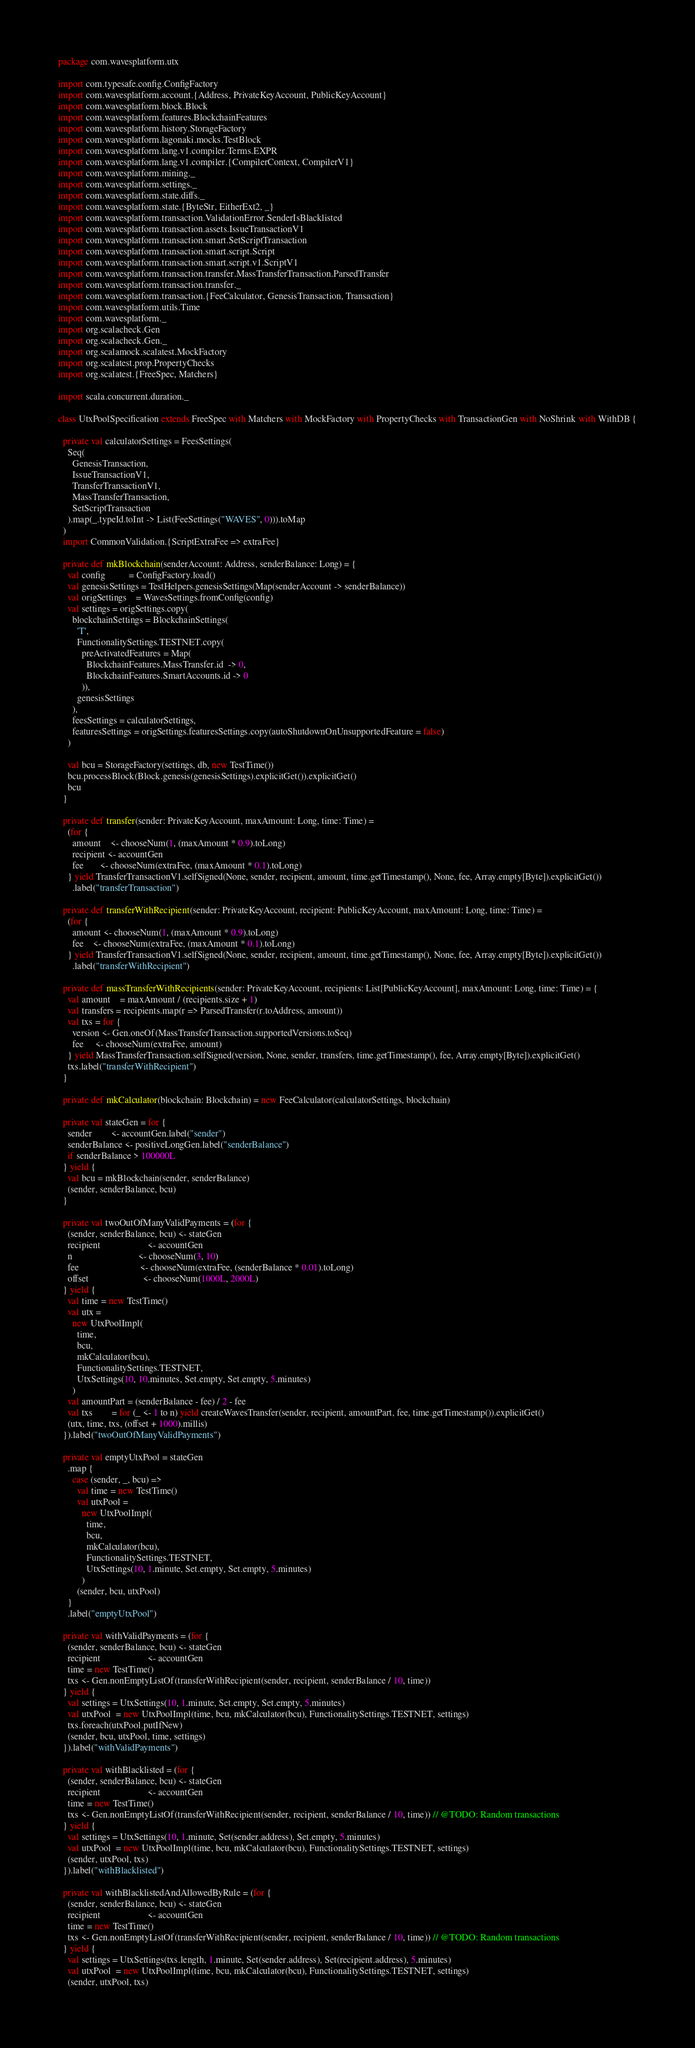<code> <loc_0><loc_0><loc_500><loc_500><_Scala_>package com.wavesplatform.utx

import com.typesafe.config.ConfigFactory
import com.wavesplatform.account.{Address, PrivateKeyAccount, PublicKeyAccount}
import com.wavesplatform.block.Block
import com.wavesplatform.features.BlockchainFeatures
import com.wavesplatform.history.StorageFactory
import com.wavesplatform.lagonaki.mocks.TestBlock
import com.wavesplatform.lang.v1.compiler.Terms.EXPR
import com.wavesplatform.lang.v1.compiler.{CompilerContext, CompilerV1}
import com.wavesplatform.mining._
import com.wavesplatform.settings._
import com.wavesplatform.state.diffs._
import com.wavesplatform.state.{ByteStr, EitherExt2, _}
import com.wavesplatform.transaction.ValidationError.SenderIsBlacklisted
import com.wavesplatform.transaction.assets.IssueTransactionV1
import com.wavesplatform.transaction.smart.SetScriptTransaction
import com.wavesplatform.transaction.smart.script.Script
import com.wavesplatform.transaction.smart.script.v1.ScriptV1
import com.wavesplatform.transaction.transfer.MassTransferTransaction.ParsedTransfer
import com.wavesplatform.transaction.transfer._
import com.wavesplatform.transaction.{FeeCalculator, GenesisTransaction, Transaction}
import com.wavesplatform.utils.Time
import com.wavesplatform._
import org.scalacheck.Gen
import org.scalacheck.Gen._
import org.scalamock.scalatest.MockFactory
import org.scalatest.prop.PropertyChecks
import org.scalatest.{FreeSpec, Matchers}

import scala.concurrent.duration._

class UtxPoolSpecification extends FreeSpec with Matchers with MockFactory with PropertyChecks with TransactionGen with NoShrink with WithDB {

  private val calculatorSettings = FeesSettings(
    Seq(
      GenesisTransaction,
      IssueTransactionV1,
      TransferTransactionV1,
      MassTransferTransaction,
      SetScriptTransaction
    ).map(_.typeId.toInt -> List(FeeSettings("WAVES", 0))).toMap
  )
  import CommonValidation.{ScriptExtraFee => extraFee}

  private def mkBlockchain(senderAccount: Address, senderBalance: Long) = {
    val config          = ConfigFactory.load()
    val genesisSettings = TestHelpers.genesisSettings(Map(senderAccount -> senderBalance))
    val origSettings    = WavesSettings.fromConfig(config)
    val settings = origSettings.copy(
      blockchainSettings = BlockchainSettings(
        'T',
        FunctionalitySettings.TESTNET.copy(
          preActivatedFeatures = Map(
            BlockchainFeatures.MassTransfer.id  -> 0,
            BlockchainFeatures.SmartAccounts.id -> 0
          )),
        genesisSettings
      ),
      feesSettings = calculatorSettings,
      featuresSettings = origSettings.featuresSettings.copy(autoShutdownOnUnsupportedFeature = false)
    )

    val bcu = StorageFactory(settings, db, new TestTime())
    bcu.processBlock(Block.genesis(genesisSettings).explicitGet()).explicitGet()
    bcu
  }

  private def transfer(sender: PrivateKeyAccount, maxAmount: Long, time: Time) =
    (for {
      amount    <- chooseNum(1, (maxAmount * 0.9).toLong)
      recipient <- accountGen
      fee       <- chooseNum(extraFee, (maxAmount * 0.1).toLong)
    } yield TransferTransactionV1.selfSigned(None, sender, recipient, amount, time.getTimestamp(), None, fee, Array.empty[Byte]).explicitGet())
      .label("transferTransaction")

  private def transferWithRecipient(sender: PrivateKeyAccount, recipient: PublicKeyAccount, maxAmount: Long, time: Time) =
    (for {
      amount <- chooseNum(1, (maxAmount * 0.9).toLong)
      fee    <- chooseNum(extraFee, (maxAmount * 0.1).toLong)
    } yield TransferTransactionV1.selfSigned(None, sender, recipient, amount, time.getTimestamp(), None, fee, Array.empty[Byte]).explicitGet())
      .label("transferWithRecipient")

  private def massTransferWithRecipients(sender: PrivateKeyAccount, recipients: List[PublicKeyAccount], maxAmount: Long, time: Time) = {
    val amount    = maxAmount / (recipients.size + 1)
    val transfers = recipients.map(r => ParsedTransfer(r.toAddress, amount))
    val txs = for {
      version <- Gen.oneOf(MassTransferTransaction.supportedVersions.toSeq)
      fee     <- chooseNum(extraFee, amount)
    } yield MassTransferTransaction.selfSigned(version, None, sender, transfers, time.getTimestamp(), fee, Array.empty[Byte]).explicitGet()
    txs.label("transferWithRecipient")
  }

  private def mkCalculator(blockchain: Blockchain) = new FeeCalculator(calculatorSettings, blockchain)

  private val stateGen = for {
    sender        <- accountGen.label("sender")
    senderBalance <- positiveLongGen.label("senderBalance")
    if senderBalance > 100000L
  } yield {
    val bcu = mkBlockchain(sender, senderBalance)
    (sender, senderBalance, bcu)
  }

  private val twoOutOfManyValidPayments = (for {
    (sender, senderBalance, bcu) <- stateGen
    recipient                    <- accountGen
    n                            <- chooseNum(3, 10)
    fee                          <- chooseNum(extraFee, (senderBalance * 0.01).toLong)
    offset                       <- chooseNum(1000L, 2000L)
  } yield {
    val time = new TestTime()
    val utx =
      new UtxPoolImpl(
        time,
        bcu,
        mkCalculator(bcu),
        FunctionalitySettings.TESTNET,
        UtxSettings(10, 10.minutes, Set.empty, Set.empty, 5.minutes)
      )
    val amountPart = (senderBalance - fee) / 2 - fee
    val txs        = for (_ <- 1 to n) yield createWavesTransfer(sender, recipient, amountPart, fee, time.getTimestamp()).explicitGet()
    (utx, time, txs, (offset + 1000).millis)
  }).label("twoOutOfManyValidPayments")

  private val emptyUtxPool = stateGen
    .map {
      case (sender, _, bcu) =>
        val time = new TestTime()
        val utxPool =
          new UtxPoolImpl(
            time,
            bcu,
            mkCalculator(bcu),
            FunctionalitySettings.TESTNET,
            UtxSettings(10, 1.minute, Set.empty, Set.empty, 5.minutes)
          )
        (sender, bcu, utxPool)
    }
    .label("emptyUtxPool")

  private val withValidPayments = (for {
    (sender, senderBalance, bcu) <- stateGen
    recipient                    <- accountGen
    time = new TestTime()
    txs <- Gen.nonEmptyListOf(transferWithRecipient(sender, recipient, senderBalance / 10, time))
  } yield {
    val settings = UtxSettings(10, 1.minute, Set.empty, Set.empty, 5.minutes)
    val utxPool  = new UtxPoolImpl(time, bcu, mkCalculator(bcu), FunctionalitySettings.TESTNET, settings)
    txs.foreach(utxPool.putIfNew)
    (sender, bcu, utxPool, time, settings)
  }).label("withValidPayments")

  private val withBlacklisted = (for {
    (sender, senderBalance, bcu) <- stateGen
    recipient                    <- accountGen
    time = new TestTime()
    txs <- Gen.nonEmptyListOf(transferWithRecipient(sender, recipient, senderBalance / 10, time)) // @TODO: Random transactions
  } yield {
    val settings = UtxSettings(10, 1.minute, Set(sender.address), Set.empty, 5.minutes)
    val utxPool  = new UtxPoolImpl(time, bcu, mkCalculator(bcu), FunctionalitySettings.TESTNET, settings)
    (sender, utxPool, txs)
  }).label("withBlacklisted")

  private val withBlacklistedAndAllowedByRule = (for {
    (sender, senderBalance, bcu) <- stateGen
    recipient                    <- accountGen
    time = new TestTime()
    txs <- Gen.nonEmptyListOf(transferWithRecipient(sender, recipient, senderBalance / 10, time)) // @TODO: Random transactions
  } yield {
    val settings = UtxSettings(txs.length, 1.minute, Set(sender.address), Set(recipient.address), 5.minutes)
    val utxPool  = new UtxPoolImpl(time, bcu, mkCalculator(bcu), FunctionalitySettings.TESTNET, settings)
    (sender, utxPool, txs)</code> 